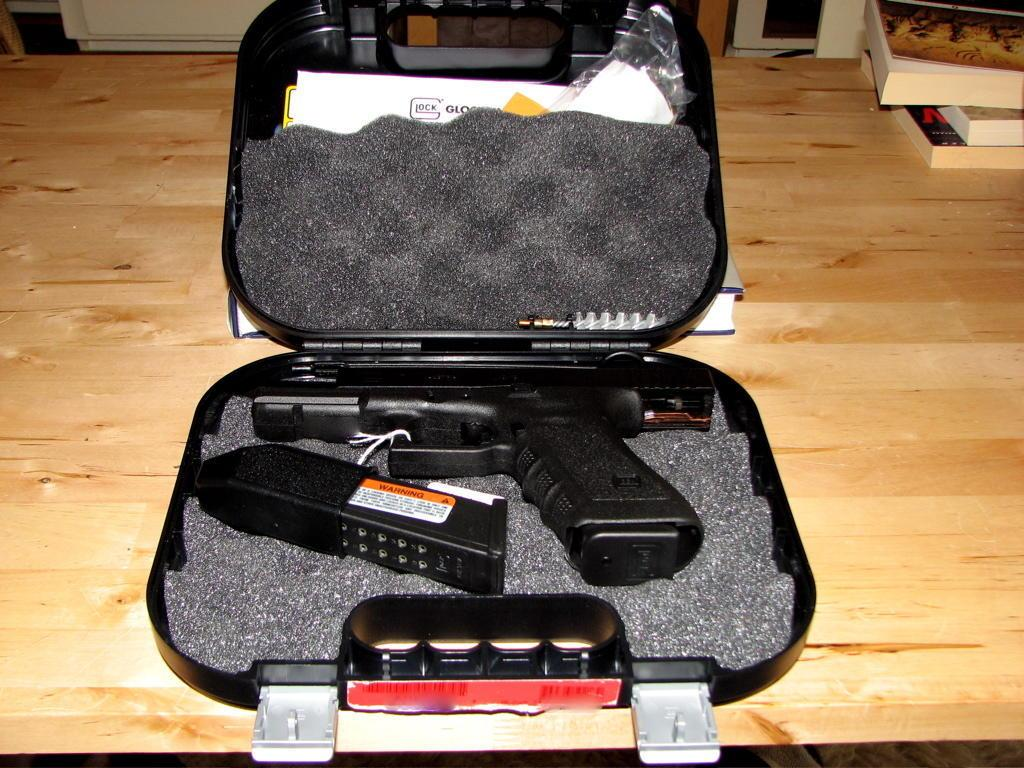What is located at the bottom of the image? There is a table at the bottom of the image. What is placed on the table? There is a suitcase on the table. What is inside the suitcase? There is a gun inside the suitcase. What can be seen in the top right side of the image? There are books in the top right side of the image. Where is the station located in the image? There is no station present in the image. What type of tree can be seen in the image? There is no tree present in the image. 